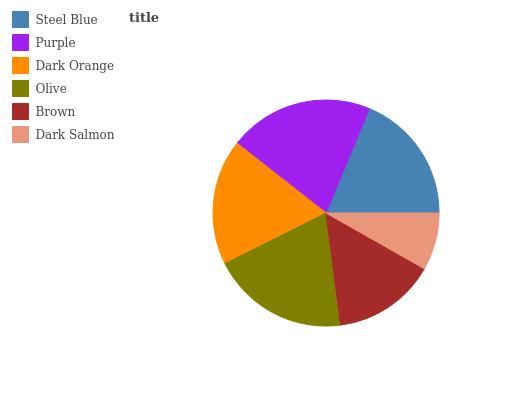Is Dark Salmon the minimum?
Answer yes or no. Yes. Is Purple the maximum?
Answer yes or no. Yes. Is Dark Orange the minimum?
Answer yes or no. No. Is Dark Orange the maximum?
Answer yes or no. No. Is Purple greater than Dark Orange?
Answer yes or no. Yes. Is Dark Orange less than Purple?
Answer yes or no. Yes. Is Dark Orange greater than Purple?
Answer yes or no. No. Is Purple less than Dark Orange?
Answer yes or no. No. Is Steel Blue the high median?
Answer yes or no. Yes. Is Dark Orange the low median?
Answer yes or no. Yes. Is Dark Salmon the high median?
Answer yes or no. No. Is Purple the low median?
Answer yes or no. No. 